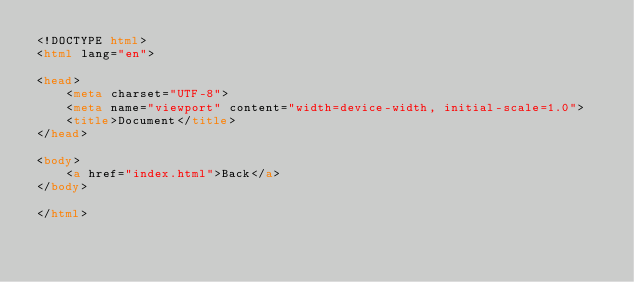<code> <loc_0><loc_0><loc_500><loc_500><_HTML_><!DOCTYPE html>
<html lang="en">

<head>
    <meta charset="UTF-8">
    <meta name="viewport" content="width=device-width, initial-scale=1.0">
    <title>Document</title>
</head>

<body>
    <a href="index.html">Back</a>
</body>

</html></code> 